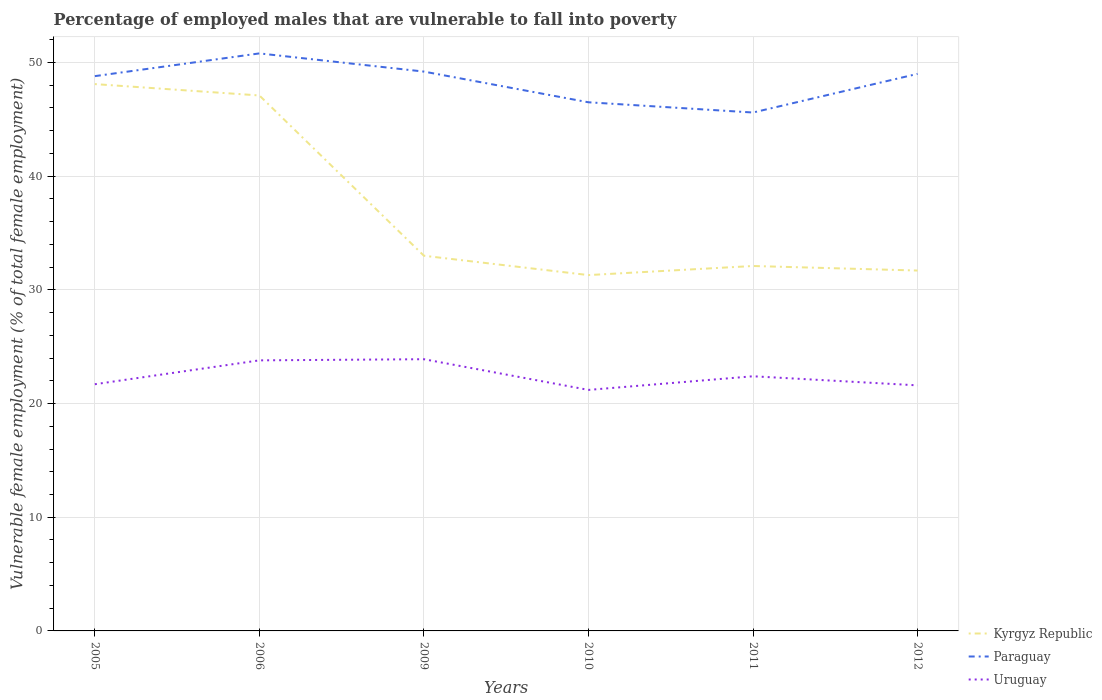How many different coloured lines are there?
Offer a very short reply. 3. Across all years, what is the maximum percentage of employed males who are vulnerable to fall into poverty in Kyrgyz Republic?
Give a very brief answer. 31.3. In which year was the percentage of employed males who are vulnerable to fall into poverty in Paraguay maximum?
Offer a very short reply. 2011. What is the total percentage of employed males who are vulnerable to fall into poverty in Uruguay in the graph?
Your answer should be very brief. 2.2. What is the difference between the highest and the second highest percentage of employed males who are vulnerable to fall into poverty in Uruguay?
Provide a succinct answer. 2.7. What is the difference between the highest and the lowest percentage of employed males who are vulnerable to fall into poverty in Uruguay?
Ensure brevity in your answer.  2. How many lines are there?
Your answer should be very brief. 3. What is the difference between two consecutive major ticks on the Y-axis?
Make the answer very short. 10. Does the graph contain any zero values?
Offer a very short reply. No. Does the graph contain grids?
Your answer should be compact. Yes. Where does the legend appear in the graph?
Your answer should be compact. Bottom right. How many legend labels are there?
Provide a succinct answer. 3. What is the title of the graph?
Your answer should be very brief. Percentage of employed males that are vulnerable to fall into poverty. What is the label or title of the Y-axis?
Offer a very short reply. Vulnerable female employment (% of total female employment). What is the Vulnerable female employment (% of total female employment) of Kyrgyz Republic in 2005?
Give a very brief answer. 48.1. What is the Vulnerable female employment (% of total female employment) of Paraguay in 2005?
Offer a very short reply. 48.8. What is the Vulnerable female employment (% of total female employment) in Uruguay in 2005?
Offer a terse response. 21.7. What is the Vulnerable female employment (% of total female employment) of Kyrgyz Republic in 2006?
Give a very brief answer. 47.1. What is the Vulnerable female employment (% of total female employment) of Paraguay in 2006?
Offer a terse response. 50.8. What is the Vulnerable female employment (% of total female employment) of Uruguay in 2006?
Give a very brief answer. 23.8. What is the Vulnerable female employment (% of total female employment) of Paraguay in 2009?
Make the answer very short. 49.2. What is the Vulnerable female employment (% of total female employment) in Uruguay in 2009?
Keep it short and to the point. 23.9. What is the Vulnerable female employment (% of total female employment) in Kyrgyz Republic in 2010?
Your response must be concise. 31.3. What is the Vulnerable female employment (% of total female employment) of Paraguay in 2010?
Give a very brief answer. 46.5. What is the Vulnerable female employment (% of total female employment) in Uruguay in 2010?
Make the answer very short. 21.2. What is the Vulnerable female employment (% of total female employment) in Kyrgyz Republic in 2011?
Your answer should be compact. 32.1. What is the Vulnerable female employment (% of total female employment) in Paraguay in 2011?
Provide a succinct answer. 45.6. What is the Vulnerable female employment (% of total female employment) of Uruguay in 2011?
Your response must be concise. 22.4. What is the Vulnerable female employment (% of total female employment) of Kyrgyz Republic in 2012?
Provide a succinct answer. 31.7. What is the Vulnerable female employment (% of total female employment) of Uruguay in 2012?
Provide a short and direct response. 21.6. Across all years, what is the maximum Vulnerable female employment (% of total female employment) of Kyrgyz Republic?
Your answer should be very brief. 48.1. Across all years, what is the maximum Vulnerable female employment (% of total female employment) of Paraguay?
Offer a very short reply. 50.8. Across all years, what is the maximum Vulnerable female employment (% of total female employment) of Uruguay?
Keep it short and to the point. 23.9. Across all years, what is the minimum Vulnerable female employment (% of total female employment) of Kyrgyz Republic?
Your response must be concise. 31.3. Across all years, what is the minimum Vulnerable female employment (% of total female employment) of Paraguay?
Your answer should be compact. 45.6. Across all years, what is the minimum Vulnerable female employment (% of total female employment) in Uruguay?
Your answer should be very brief. 21.2. What is the total Vulnerable female employment (% of total female employment) in Kyrgyz Republic in the graph?
Offer a very short reply. 223.3. What is the total Vulnerable female employment (% of total female employment) of Paraguay in the graph?
Your response must be concise. 289.9. What is the total Vulnerable female employment (% of total female employment) in Uruguay in the graph?
Offer a terse response. 134.6. What is the difference between the Vulnerable female employment (% of total female employment) in Kyrgyz Republic in 2005 and that in 2006?
Keep it short and to the point. 1. What is the difference between the Vulnerable female employment (% of total female employment) of Uruguay in 2005 and that in 2006?
Your answer should be very brief. -2.1. What is the difference between the Vulnerable female employment (% of total female employment) in Kyrgyz Republic in 2005 and that in 2009?
Offer a very short reply. 15.1. What is the difference between the Vulnerable female employment (% of total female employment) in Uruguay in 2005 and that in 2010?
Your answer should be very brief. 0.5. What is the difference between the Vulnerable female employment (% of total female employment) in Uruguay in 2005 and that in 2011?
Offer a terse response. -0.7. What is the difference between the Vulnerable female employment (% of total female employment) in Kyrgyz Republic in 2006 and that in 2009?
Offer a very short reply. 14.1. What is the difference between the Vulnerable female employment (% of total female employment) in Paraguay in 2006 and that in 2009?
Offer a very short reply. 1.6. What is the difference between the Vulnerable female employment (% of total female employment) of Kyrgyz Republic in 2006 and that in 2010?
Make the answer very short. 15.8. What is the difference between the Vulnerable female employment (% of total female employment) in Paraguay in 2006 and that in 2010?
Ensure brevity in your answer.  4.3. What is the difference between the Vulnerable female employment (% of total female employment) of Uruguay in 2006 and that in 2010?
Offer a very short reply. 2.6. What is the difference between the Vulnerable female employment (% of total female employment) of Kyrgyz Republic in 2006 and that in 2011?
Your answer should be compact. 15. What is the difference between the Vulnerable female employment (% of total female employment) in Paraguay in 2006 and that in 2011?
Provide a short and direct response. 5.2. What is the difference between the Vulnerable female employment (% of total female employment) of Paraguay in 2006 and that in 2012?
Your answer should be compact. 1.8. What is the difference between the Vulnerable female employment (% of total female employment) of Uruguay in 2006 and that in 2012?
Offer a terse response. 2.2. What is the difference between the Vulnerable female employment (% of total female employment) in Kyrgyz Republic in 2009 and that in 2010?
Offer a terse response. 1.7. What is the difference between the Vulnerable female employment (% of total female employment) in Paraguay in 2009 and that in 2011?
Your response must be concise. 3.6. What is the difference between the Vulnerable female employment (% of total female employment) of Uruguay in 2009 and that in 2011?
Ensure brevity in your answer.  1.5. What is the difference between the Vulnerable female employment (% of total female employment) of Kyrgyz Republic in 2009 and that in 2012?
Offer a terse response. 1.3. What is the difference between the Vulnerable female employment (% of total female employment) of Paraguay in 2009 and that in 2012?
Offer a terse response. 0.2. What is the difference between the Vulnerable female employment (% of total female employment) in Kyrgyz Republic in 2010 and that in 2012?
Your answer should be very brief. -0.4. What is the difference between the Vulnerable female employment (% of total female employment) in Uruguay in 2010 and that in 2012?
Offer a very short reply. -0.4. What is the difference between the Vulnerable female employment (% of total female employment) of Paraguay in 2011 and that in 2012?
Provide a succinct answer. -3.4. What is the difference between the Vulnerable female employment (% of total female employment) in Kyrgyz Republic in 2005 and the Vulnerable female employment (% of total female employment) in Paraguay in 2006?
Offer a very short reply. -2.7. What is the difference between the Vulnerable female employment (% of total female employment) of Kyrgyz Republic in 2005 and the Vulnerable female employment (% of total female employment) of Uruguay in 2006?
Keep it short and to the point. 24.3. What is the difference between the Vulnerable female employment (% of total female employment) in Kyrgyz Republic in 2005 and the Vulnerable female employment (% of total female employment) in Paraguay in 2009?
Offer a very short reply. -1.1. What is the difference between the Vulnerable female employment (% of total female employment) of Kyrgyz Republic in 2005 and the Vulnerable female employment (% of total female employment) of Uruguay in 2009?
Keep it short and to the point. 24.2. What is the difference between the Vulnerable female employment (% of total female employment) of Paraguay in 2005 and the Vulnerable female employment (% of total female employment) of Uruguay in 2009?
Make the answer very short. 24.9. What is the difference between the Vulnerable female employment (% of total female employment) of Kyrgyz Republic in 2005 and the Vulnerable female employment (% of total female employment) of Paraguay in 2010?
Your answer should be very brief. 1.6. What is the difference between the Vulnerable female employment (% of total female employment) of Kyrgyz Republic in 2005 and the Vulnerable female employment (% of total female employment) of Uruguay in 2010?
Provide a succinct answer. 26.9. What is the difference between the Vulnerable female employment (% of total female employment) of Paraguay in 2005 and the Vulnerable female employment (% of total female employment) of Uruguay in 2010?
Your answer should be compact. 27.6. What is the difference between the Vulnerable female employment (% of total female employment) in Kyrgyz Republic in 2005 and the Vulnerable female employment (% of total female employment) in Paraguay in 2011?
Keep it short and to the point. 2.5. What is the difference between the Vulnerable female employment (% of total female employment) of Kyrgyz Republic in 2005 and the Vulnerable female employment (% of total female employment) of Uruguay in 2011?
Give a very brief answer. 25.7. What is the difference between the Vulnerable female employment (% of total female employment) in Paraguay in 2005 and the Vulnerable female employment (% of total female employment) in Uruguay in 2011?
Your answer should be compact. 26.4. What is the difference between the Vulnerable female employment (% of total female employment) of Paraguay in 2005 and the Vulnerable female employment (% of total female employment) of Uruguay in 2012?
Keep it short and to the point. 27.2. What is the difference between the Vulnerable female employment (% of total female employment) in Kyrgyz Republic in 2006 and the Vulnerable female employment (% of total female employment) in Paraguay in 2009?
Provide a succinct answer. -2.1. What is the difference between the Vulnerable female employment (% of total female employment) of Kyrgyz Republic in 2006 and the Vulnerable female employment (% of total female employment) of Uruguay in 2009?
Ensure brevity in your answer.  23.2. What is the difference between the Vulnerable female employment (% of total female employment) in Paraguay in 2006 and the Vulnerable female employment (% of total female employment) in Uruguay in 2009?
Make the answer very short. 26.9. What is the difference between the Vulnerable female employment (% of total female employment) in Kyrgyz Republic in 2006 and the Vulnerable female employment (% of total female employment) in Uruguay in 2010?
Keep it short and to the point. 25.9. What is the difference between the Vulnerable female employment (% of total female employment) in Paraguay in 2006 and the Vulnerable female employment (% of total female employment) in Uruguay in 2010?
Make the answer very short. 29.6. What is the difference between the Vulnerable female employment (% of total female employment) in Kyrgyz Republic in 2006 and the Vulnerable female employment (% of total female employment) in Paraguay in 2011?
Offer a very short reply. 1.5. What is the difference between the Vulnerable female employment (% of total female employment) in Kyrgyz Republic in 2006 and the Vulnerable female employment (% of total female employment) in Uruguay in 2011?
Offer a terse response. 24.7. What is the difference between the Vulnerable female employment (% of total female employment) in Paraguay in 2006 and the Vulnerable female employment (% of total female employment) in Uruguay in 2011?
Offer a terse response. 28.4. What is the difference between the Vulnerable female employment (% of total female employment) of Paraguay in 2006 and the Vulnerable female employment (% of total female employment) of Uruguay in 2012?
Ensure brevity in your answer.  29.2. What is the difference between the Vulnerable female employment (% of total female employment) of Kyrgyz Republic in 2009 and the Vulnerable female employment (% of total female employment) of Uruguay in 2010?
Your answer should be very brief. 11.8. What is the difference between the Vulnerable female employment (% of total female employment) in Paraguay in 2009 and the Vulnerable female employment (% of total female employment) in Uruguay in 2010?
Keep it short and to the point. 28. What is the difference between the Vulnerable female employment (% of total female employment) in Kyrgyz Republic in 2009 and the Vulnerable female employment (% of total female employment) in Uruguay in 2011?
Offer a terse response. 10.6. What is the difference between the Vulnerable female employment (% of total female employment) of Paraguay in 2009 and the Vulnerable female employment (% of total female employment) of Uruguay in 2011?
Provide a short and direct response. 26.8. What is the difference between the Vulnerable female employment (% of total female employment) of Paraguay in 2009 and the Vulnerable female employment (% of total female employment) of Uruguay in 2012?
Make the answer very short. 27.6. What is the difference between the Vulnerable female employment (% of total female employment) in Kyrgyz Republic in 2010 and the Vulnerable female employment (% of total female employment) in Paraguay in 2011?
Provide a succinct answer. -14.3. What is the difference between the Vulnerable female employment (% of total female employment) of Kyrgyz Republic in 2010 and the Vulnerable female employment (% of total female employment) of Uruguay in 2011?
Your answer should be very brief. 8.9. What is the difference between the Vulnerable female employment (% of total female employment) in Paraguay in 2010 and the Vulnerable female employment (% of total female employment) in Uruguay in 2011?
Make the answer very short. 24.1. What is the difference between the Vulnerable female employment (% of total female employment) in Kyrgyz Republic in 2010 and the Vulnerable female employment (% of total female employment) in Paraguay in 2012?
Offer a very short reply. -17.7. What is the difference between the Vulnerable female employment (% of total female employment) of Paraguay in 2010 and the Vulnerable female employment (% of total female employment) of Uruguay in 2012?
Offer a very short reply. 24.9. What is the difference between the Vulnerable female employment (% of total female employment) in Kyrgyz Republic in 2011 and the Vulnerable female employment (% of total female employment) in Paraguay in 2012?
Your response must be concise. -16.9. What is the difference between the Vulnerable female employment (% of total female employment) in Kyrgyz Republic in 2011 and the Vulnerable female employment (% of total female employment) in Uruguay in 2012?
Provide a succinct answer. 10.5. What is the average Vulnerable female employment (% of total female employment) of Kyrgyz Republic per year?
Your answer should be very brief. 37.22. What is the average Vulnerable female employment (% of total female employment) in Paraguay per year?
Give a very brief answer. 48.32. What is the average Vulnerable female employment (% of total female employment) of Uruguay per year?
Offer a very short reply. 22.43. In the year 2005, what is the difference between the Vulnerable female employment (% of total female employment) of Kyrgyz Republic and Vulnerable female employment (% of total female employment) of Paraguay?
Keep it short and to the point. -0.7. In the year 2005, what is the difference between the Vulnerable female employment (% of total female employment) of Kyrgyz Republic and Vulnerable female employment (% of total female employment) of Uruguay?
Your answer should be very brief. 26.4. In the year 2005, what is the difference between the Vulnerable female employment (% of total female employment) in Paraguay and Vulnerable female employment (% of total female employment) in Uruguay?
Your response must be concise. 27.1. In the year 2006, what is the difference between the Vulnerable female employment (% of total female employment) of Kyrgyz Republic and Vulnerable female employment (% of total female employment) of Uruguay?
Make the answer very short. 23.3. In the year 2006, what is the difference between the Vulnerable female employment (% of total female employment) of Paraguay and Vulnerable female employment (% of total female employment) of Uruguay?
Offer a very short reply. 27. In the year 2009, what is the difference between the Vulnerable female employment (% of total female employment) of Kyrgyz Republic and Vulnerable female employment (% of total female employment) of Paraguay?
Ensure brevity in your answer.  -16.2. In the year 2009, what is the difference between the Vulnerable female employment (% of total female employment) in Paraguay and Vulnerable female employment (% of total female employment) in Uruguay?
Provide a short and direct response. 25.3. In the year 2010, what is the difference between the Vulnerable female employment (% of total female employment) in Kyrgyz Republic and Vulnerable female employment (% of total female employment) in Paraguay?
Offer a terse response. -15.2. In the year 2010, what is the difference between the Vulnerable female employment (% of total female employment) in Paraguay and Vulnerable female employment (% of total female employment) in Uruguay?
Keep it short and to the point. 25.3. In the year 2011, what is the difference between the Vulnerable female employment (% of total female employment) in Kyrgyz Republic and Vulnerable female employment (% of total female employment) in Paraguay?
Your answer should be very brief. -13.5. In the year 2011, what is the difference between the Vulnerable female employment (% of total female employment) in Paraguay and Vulnerable female employment (% of total female employment) in Uruguay?
Make the answer very short. 23.2. In the year 2012, what is the difference between the Vulnerable female employment (% of total female employment) in Kyrgyz Republic and Vulnerable female employment (% of total female employment) in Paraguay?
Make the answer very short. -17.3. In the year 2012, what is the difference between the Vulnerable female employment (% of total female employment) in Kyrgyz Republic and Vulnerable female employment (% of total female employment) in Uruguay?
Keep it short and to the point. 10.1. In the year 2012, what is the difference between the Vulnerable female employment (% of total female employment) in Paraguay and Vulnerable female employment (% of total female employment) in Uruguay?
Give a very brief answer. 27.4. What is the ratio of the Vulnerable female employment (% of total female employment) of Kyrgyz Republic in 2005 to that in 2006?
Your answer should be compact. 1.02. What is the ratio of the Vulnerable female employment (% of total female employment) of Paraguay in 2005 to that in 2006?
Keep it short and to the point. 0.96. What is the ratio of the Vulnerable female employment (% of total female employment) of Uruguay in 2005 to that in 2006?
Keep it short and to the point. 0.91. What is the ratio of the Vulnerable female employment (% of total female employment) in Kyrgyz Republic in 2005 to that in 2009?
Keep it short and to the point. 1.46. What is the ratio of the Vulnerable female employment (% of total female employment) in Paraguay in 2005 to that in 2009?
Provide a short and direct response. 0.99. What is the ratio of the Vulnerable female employment (% of total female employment) in Uruguay in 2005 to that in 2009?
Give a very brief answer. 0.91. What is the ratio of the Vulnerable female employment (% of total female employment) in Kyrgyz Republic in 2005 to that in 2010?
Offer a very short reply. 1.54. What is the ratio of the Vulnerable female employment (% of total female employment) of Paraguay in 2005 to that in 2010?
Keep it short and to the point. 1.05. What is the ratio of the Vulnerable female employment (% of total female employment) of Uruguay in 2005 to that in 2010?
Offer a terse response. 1.02. What is the ratio of the Vulnerable female employment (% of total female employment) in Kyrgyz Republic in 2005 to that in 2011?
Your answer should be very brief. 1.5. What is the ratio of the Vulnerable female employment (% of total female employment) in Paraguay in 2005 to that in 2011?
Offer a very short reply. 1.07. What is the ratio of the Vulnerable female employment (% of total female employment) of Uruguay in 2005 to that in 2011?
Provide a succinct answer. 0.97. What is the ratio of the Vulnerable female employment (% of total female employment) of Kyrgyz Republic in 2005 to that in 2012?
Make the answer very short. 1.52. What is the ratio of the Vulnerable female employment (% of total female employment) of Paraguay in 2005 to that in 2012?
Offer a terse response. 1. What is the ratio of the Vulnerable female employment (% of total female employment) in Kyrgyz Republic in 2006 to that in 2009?
Your response must be concise. 1.43. What is the ratio of the Vulnerable female employment (% of total female employment) in Paraguay in 2006 to that in 2009?
Your answer should be very brief. 1.03. What is the ratio of the Vulnerable female employment (% of total female employment) of Uruguay in 2006 to that in 2009?
Your response must be concise. 1. What is the ratio of the Vulnerable female employment (% of total female employment) of Kyrgyz Republic in 2006 to that in 2010?
Offer a very short reply. 1.5. What is the ratio of the Vulnerable female employment (% of total female employment) in Paraguay in 2006 to that in 2010?
Ensure brevity in your answer.  1.09. What is the ratio of the Vulnerable female employment (% of total female employment) in Uruguay in 2006 to that in 2010?
Your answer should be compact. 1.12. What is the ratio of the Vulnerable female employment (% of total female employment) of Kyrgyz Republic in 2006 to that in 2011?
Provide a short and direct response. 1.47. What is the ratio of the Vulnerable female employment (% of total female employment) in Paraguay in 2006 to that in 2011?
Ensure brevity in your answer.  1.11. What is the ratio of the Vulnerable female employment (% of total female employment) of Kyrgyz Republic in 2006 to that in 2012?
Ensure brevity in your answer.  1.49. What is the ratio of the Vulnerable female employment (% of total female employment) of Paraguay in 2006 to that in 2012?
Offer a terse response. 1.04. What is the ratio of the Vulnerable female employment (% of total female employment) of Uruguay in 2006 to that in 2012?
Offer a very short reply. 1.1. What is the ratio of the Vulnerable female employment (% of total female employment) in Kyrgyz Republic in 2009 to that in 2010?
Give a very brief answer. 1.05. What is the ratio of the Vulnerable female employment (% of total female employment) of Paraguay in 2009 to that in 2010?
Provide a short and direct response. 1.06. What is the ratio of the Vulnerable female employment (% of total female employment) of Uruguay in 2009 to that in 2010?
Ensure brevity in your answer.  1.13. What is the ratio of the Vulnerable female employment (% of total female employment) of Kyrgyz Republic in 2009 to that in 2011?
Provide a short and direct response. 1.03. What is the ratio of the Vulnerable female employment (% of total female employment) in Paraguay in 2009 to that in 2011?
Keep it short and to the point. 1.08. What is the ratio of the Vulnerable female employment (% of total female employment) of Uruguay in 2009 to that in 2011?
Give a very brief answer. 1.07. What is the ratio of the Vulnerable female employment (% of total female employment) of Kyrgyz Republic in 2009 to that in 2012?
Your response must be concise. 1.04. What is the ratio of the Vulnerable female employment (% of total female employment) in Paraguay in 2009 to that in 2012?
Keep it short and to the point. 1. What is the ratio of the Vulnerable female employment (% of total female employment) in Uruguay in 2009 to that in 2012?
Ensure brevity in your answer.  1.11. What is the ratio of the Vulnerable female employment (% of total female employment) in Kyrgyz Republic in 2010 to that in 2011?
Ensure brevity in your answer.  0.98. What is the ratio of the Vulnerable female employment (% of total female employment) of Paraguay in 2010 to that in 2011?
Give a very brief answer. 1.02. What is the ratio of the Vulnerable female employment (% of total female employment) in Uruguay in 2010 to that in 2011?
Your answer should be very brief. 0.95. What is the ratio of the Vulnerable female employment (% of total female employment) in Kyrgyz Republic in 2010 to that in 2012?
Provide a short and direct response. 0.99. What is the ratio of the Vulnerable female employment (% of total female employment) of Paraguay in 2010 to that in 2012?
Keep it short and to the point. 0.95. What is the ratio of the Vulnerable female employment (% of total female employment) in Uruguay in 2010 to that in 2012?
Offer a very short reply. 0.98. What is the ratio of the Vulnerable female employment (% of total female employment) of Kyrgyz Republic in 2011 to that in 2012?
Ensure brevity in your answer.  1.01. What is the ratio of the Vulnerable female employment (% of total female employment) of Paraguay in 2011 to that in 2012?
Your answer should be compact. 0.93. What is the ratio of the Vulnerable female employment (% of total female employment) of Uruguay in 2011 to that in 2012?
Offer a very short reply. 1.04. What is the difference between the highest and the second highest Vulnerable female employment (% of total female employment) in Kyrgyz Republic?
Provide a succinct answer. 1. What is the difference between the highest and the second highest Vulnerable female employment (% of total female employment) in Uruguay?
Give a very brief answer. 0.1. What is the difference between the highest and the lowest Vulnerable female employment (% of total female employment) in Paraguay?
Provide a short and direct response. 5.2. What is the difference between the highest and the lowest Vulnerable female employment (% of total female employment) in Uruguay?
Your answer should be very brief. 2.7. 